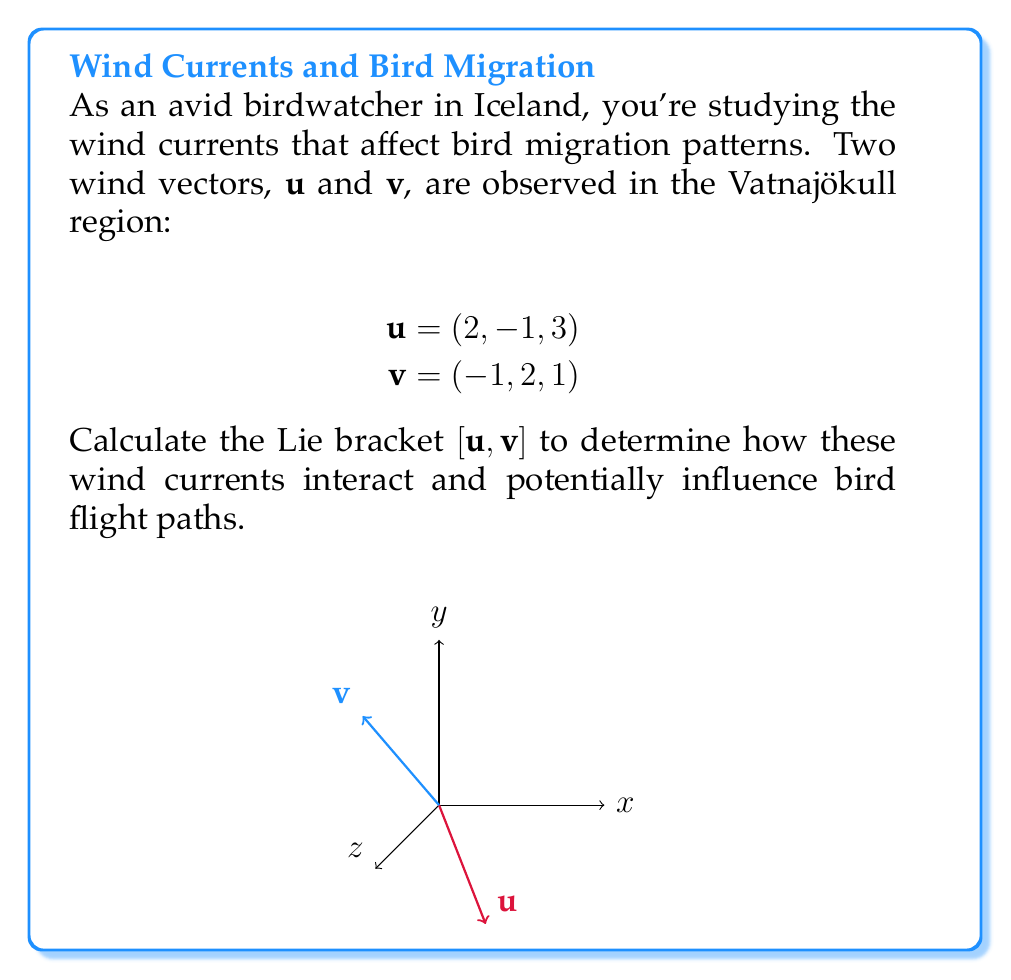Show me your answer to this math problem. To calculate the Lie bracket $[\mathbf{u}, \mathbf{v}]$, we use the formula:

$$[\mathbf{u}, \mathbf{v}] = (\mathbf{u} \cdot \nabla)\mathbf{v} - (\mathbf{v} \cdot \nabla)\mathbf{u}$$

Where $\nabla = (\frac{\partial}{\partial x}, \frac{\partial}{\partial y}, \frac{\partial}{\partial z})$.

Step 1: Calculate $(\mathbf{u} \cdot \nabla)\mathbf{v}$
$$(\mathbf{u} \cdot \nabla)\mathbf{v} = (2\frac{\partial}{\partial x} - \frac{\partial}{\partial y} + 3\frac{\partial}{\partial z})(-1, 2, 1) = (0, 0, 0)$$

Step 2: Calculate $(\mathbf{v} \cdot \nabla)\mathbf{u}$
$$(\mathbf{v} \cdot \nabla)\mathbf{u} = (-\frac{\partial}{\partial x} + 2\frac{\partial}{\partial y} + \frac{\partial}{\partial z})(2, -1, 3) = (0, 0, 0)$$

Step 3: Calculate the Lie bracket
$$[\mathbf{u}, \mathbf{v}] = (\mathbf{u} \cdot \nabla)\mathbf{v} - (\mathbf{v} \cdot \nabla)\mathbf{u} = (0, 0, 0) - (0, 0, 0) = (0, 0, 0)$$

The Lie bracket is zero, indicating that these wind currents commute and do not produce any additional effect when combined.
Answer: $(0, 0, 0)$ 